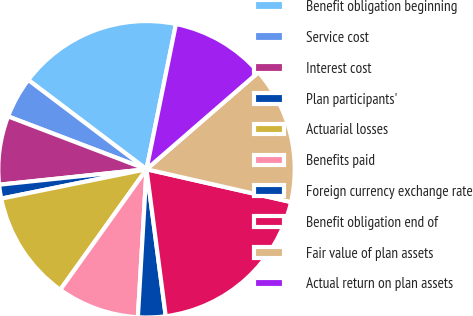Convert chart. <chart><loc_0><loc_0><loc_500><loc_500><pie_chart><fcel>Benefit obligation beginning<fcel>Service cost<fcel>Interest cost<fcel>Plan participants'<fcel>Actuarial losses<fcel>Benefits paid<fcel>Foreign currency exchange rate<fcel>Benefit obligation end of<fcel>Fair value of plan assets<fcel>Actual return on plan assets<nl><fcel>17.89%<fcel>4.49%<fcel>7.47%<fcel>1.51%<fcel>11.94%<fcel>8.96%<fcel>3.0%<fcel>19.38%<fcel>14.92%<fcel>10.45%<nl></chart> 